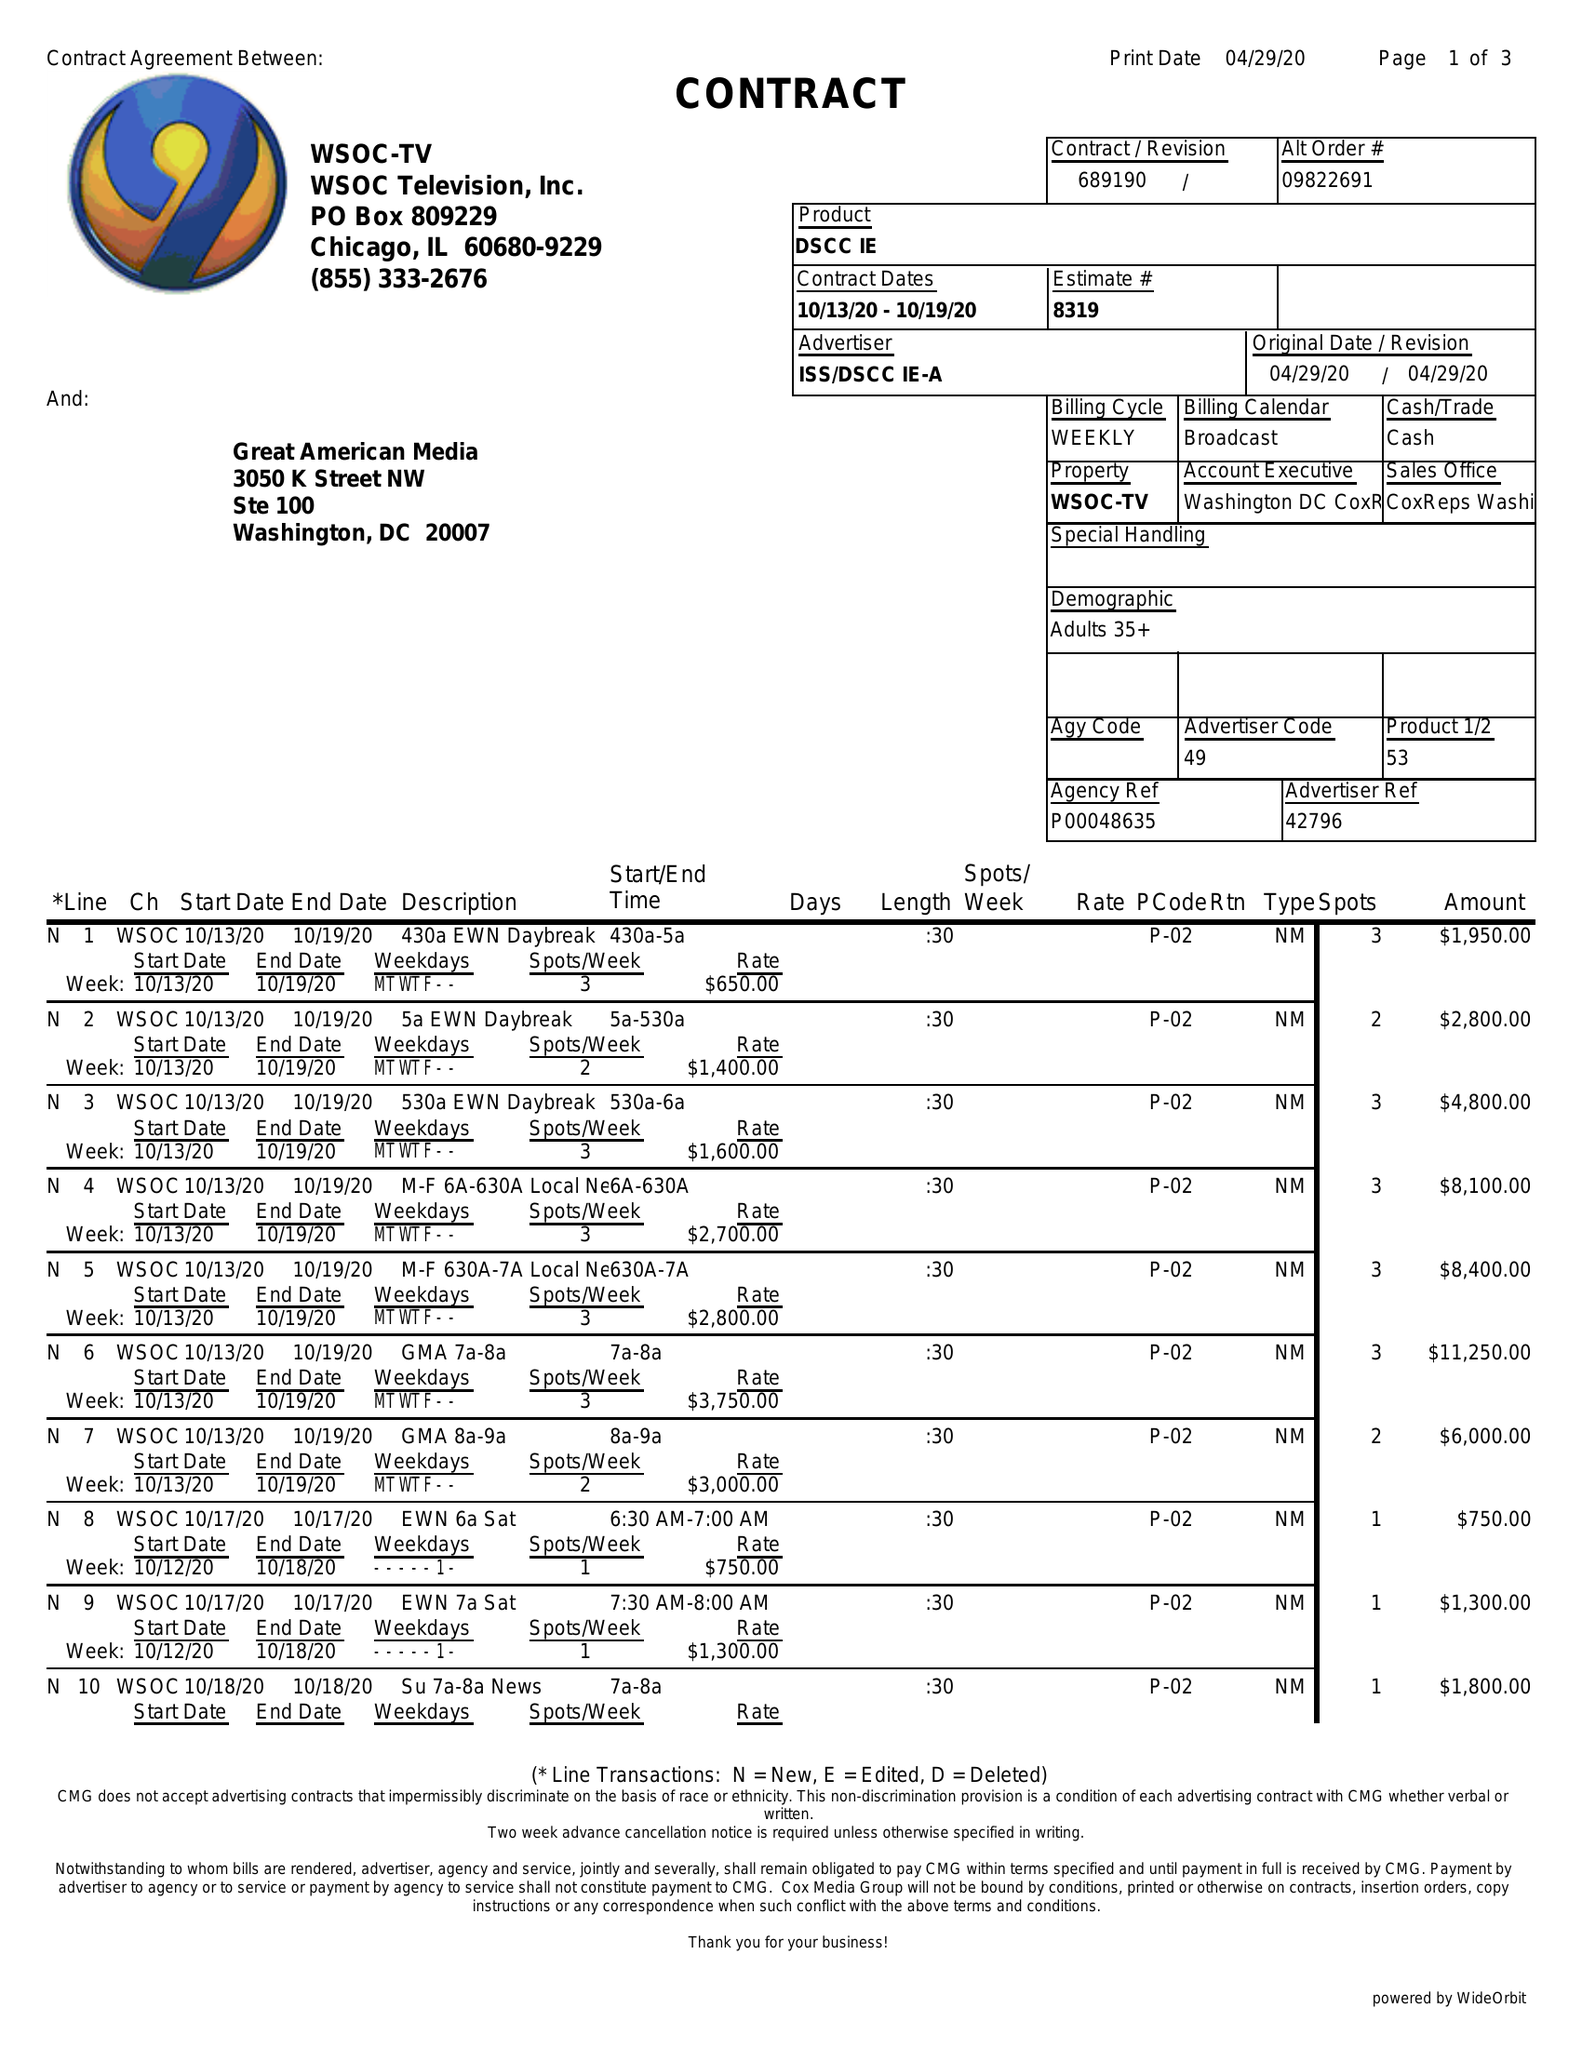What is the value for the flight_to?
Answer the question using a single word or phrase. 10/19/20 